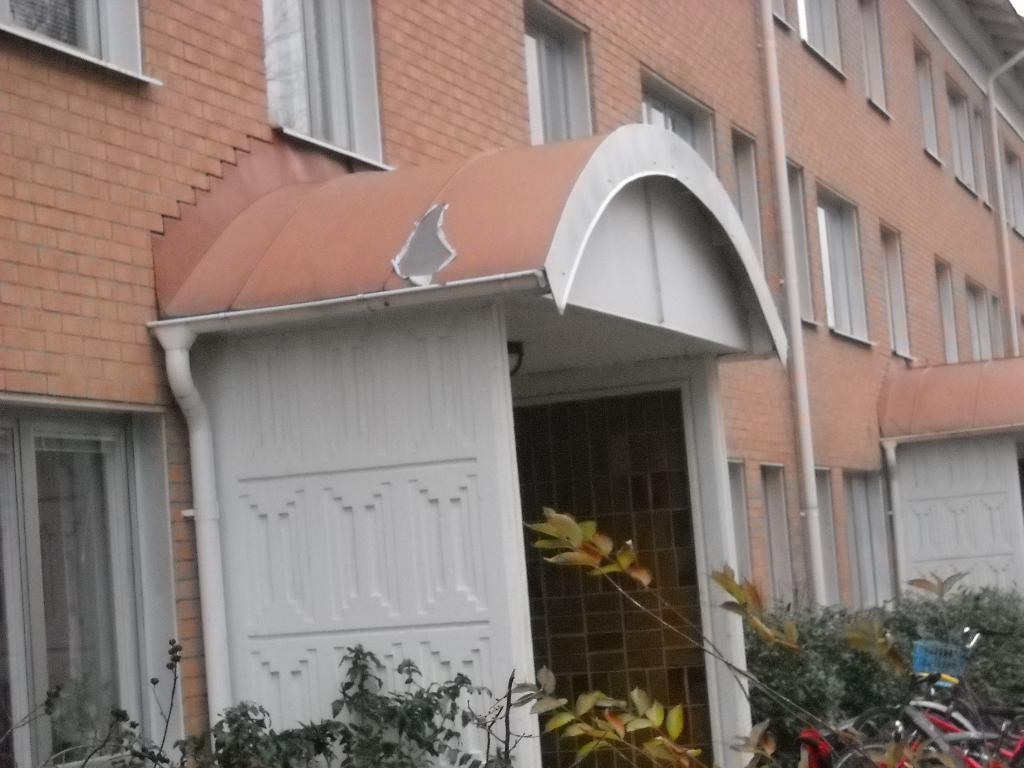What is the main structure in the image? There is a building in the image. What is connected to the building? Pipes are attached to the building. What type of vegetation is near the building? There are plants near the building. What mode of transportation can be seen near the building? There are bicycles near the building. How many passengers are sitting in the tub near the building? There is no tub or passengers present in the image. 